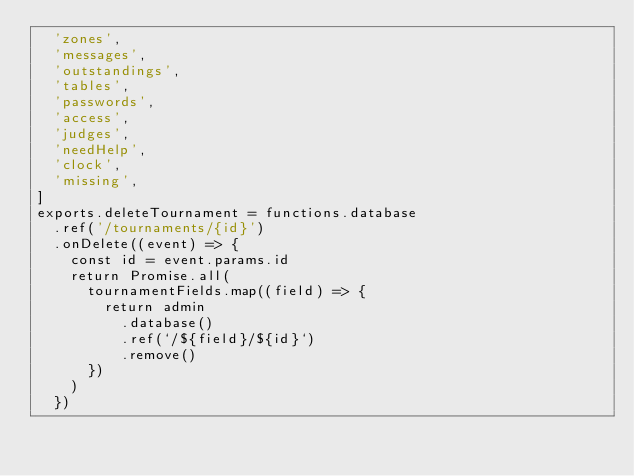Convert code to text. <code><loc_0><loc_0><loc_500><loc_500><_JavaScript_>  'zones',
  'messages',
  'outstandings',
  'tables',
  'passwords',
  'access',
  'judges',
  'needHelp',
  'clock',
  'missing',
]
exports.deleteTournament = functions.database
  .ref('/tournaments/{id}')
  .onDelete((event) => {
    const id = event.params.id
    return Promise.all(
      tournamentFields.map((field) => {
        return admin
          .database()
          .ref(`/${field}/${id}`)
          .remove()
      })
    )
  })
</code> 